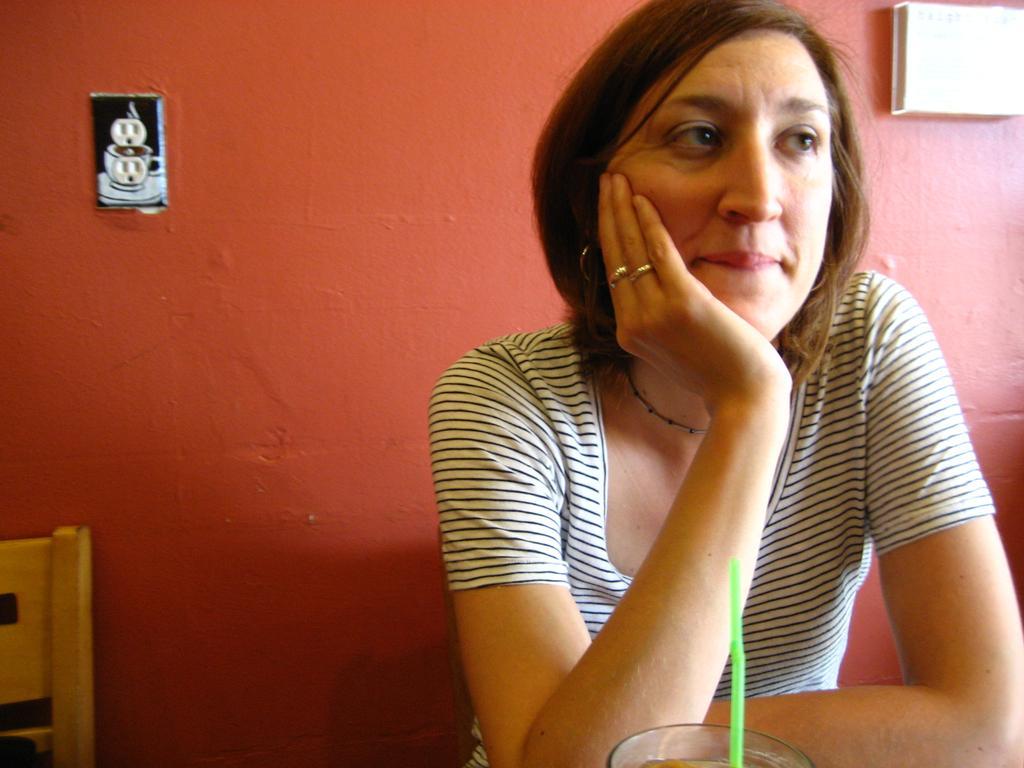Please provide a concise description of this image. In this picture there is a woman sitting. In the foreground there is a straw in the glass. On the left side of the image there is a chair. At the back there are objects on the wall. 